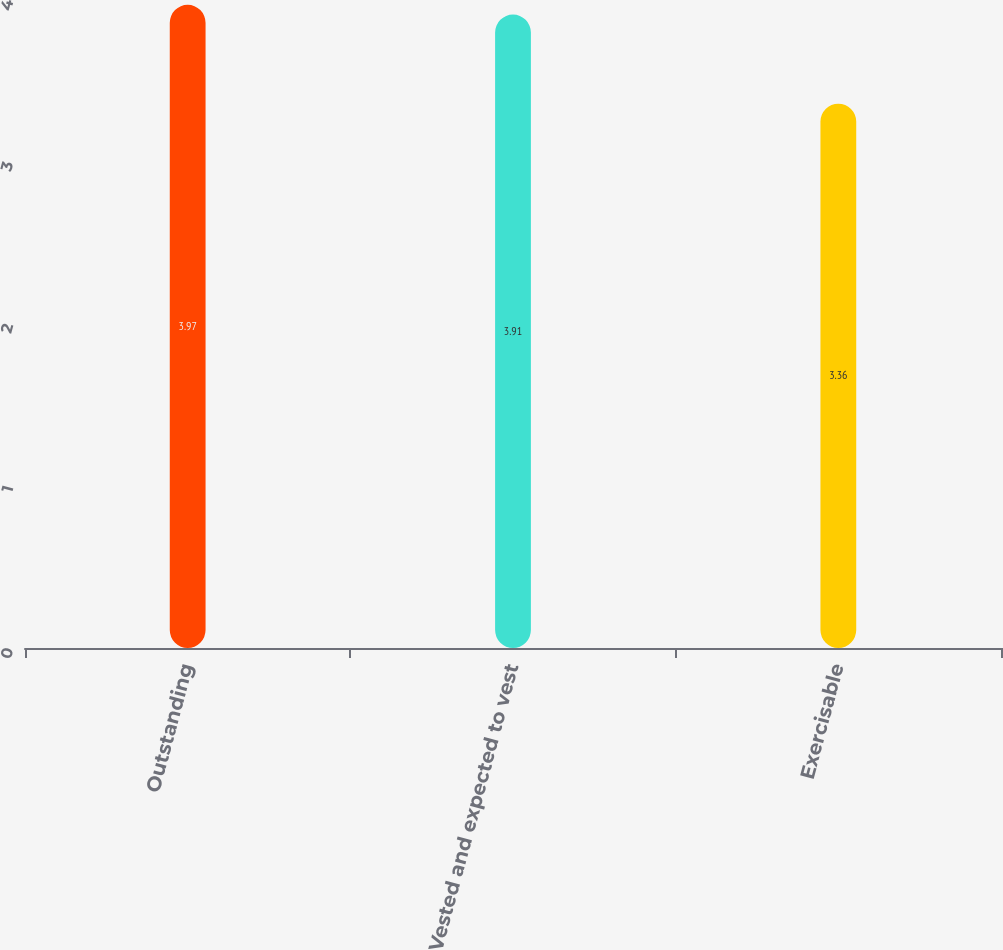Convert chart to OTSL. <chart><loc_0><loc_0><loc_500><loc_500><bar_chart><fcel>Outstanding<fcel>Vested and expected to vest<fcel>Exercisable<nl><fcel>3.97<fcel>3.91<fcel>3.36<nl></chart> 